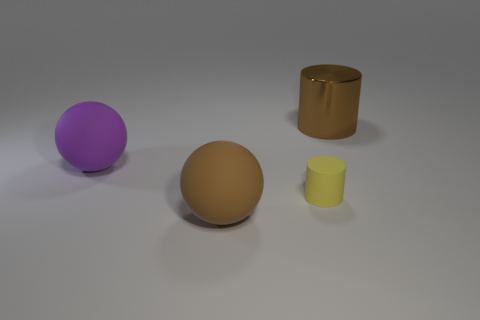The brown thing that is the same material as the purple ball is what size?
Provide a short and direct response. Large. Do the big cylinder and the tiny rubber object have the same color?
Keep it short and to the point. No. There is a big rubber thing that is to the right of the purple matte ball; is it the same shape as the tiny matte thing?
Your response must be concise. No. How many yellow rubber things have the same size as the metallic cylinder?
Ensure brevity in your answer.  0. The matte object that is the same color as the large metal object is what shape?
Provide a succinct answer. Sphere. There is a brown thing that is behind the brown ball; are there any small matte cylinders right of it?
Keep it short and to the point. No. How many objects are either cylinders that are behind the large purple object or big red metal balls?
Your answer should be compact. 1. What number of big shiny objects are there?
Your response must be concise. 1. What shape is the large purple thing that is made of the same material as the yellow cylinder?
Offer a terse response. Sphere. There is a rubber ball in front of the large ball behind the small matte thing; what size is it?
Your response must be concise. Large. 